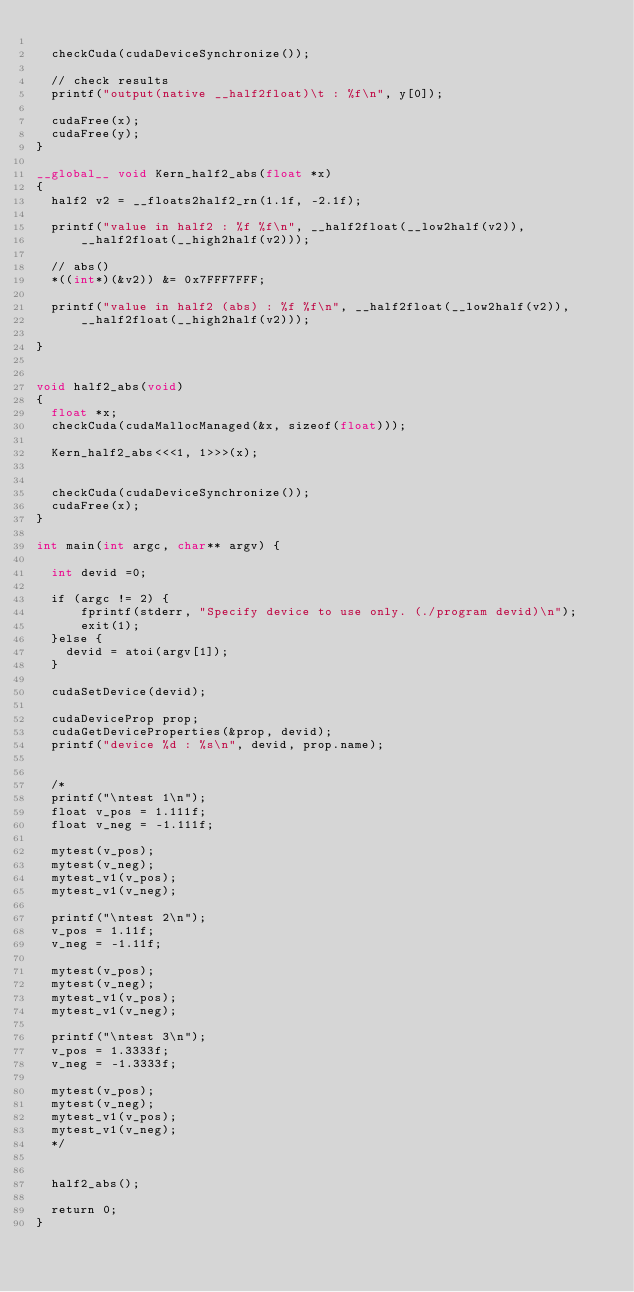<code> <loc_0><loc_0><loc_500><loc_500><_Cuda_>
  checkCuda(cudaDeviceSynchronize());
  
  // check results
  printf("output(native __half2float)\t : %f\n", y[0]);

  cudaFree(x);
  cudaFree(y);
}

__global__ void Kern_half2_abs(float *x)
{
	half2 v2 = __floats2half2_rn(1.1f, -2.1f);

	printf("value in half2 : %f %f\n", __half2float(__low2half(v2)),
			__half2float(__high2half(v2)));

	// abs()
	*((int*)(&v2)) &= 0x7FFF7FFF;

	printf("value in half2 (abs) : %f %f\n", __half2float(__low2half(v2)),
			__half2float(__high2half(v2)));

}


void half2_abs(void)
{
  float *x;
  checkCuda(cudaMallocManaged(&x, sizeof(float)));

  Kern_half2_abs<<<1, 1>>>(x);


  checkCuda(cudaDeviceSynchronize());
  cudaFree(x);
}

int main(int argc, char** argv) {

  int devid =0;

  if (argc != 2) {
      fprintf(stderr, "Specify device to use only. (./program devid)\n");
      exit(1);
  }else {
  	devid = atoi(argv[1]);
  }

  cudaSetDevice(devid);

  cudaDeviceProp prop;                                                    
  cudaGetDeviceProperties(&prop, devid);                                 
  printf("device %d : %s\n", devid, prop.name);


  /*
  printf("\ntest 1\n");
  float v_pos = 1.111f;
  float v_neg = -1.111f;

  mytest(v_pos);
  mytest(v_neg);
  mytest_v1(v_pos);
  mytest_v1(v_neg);

  printf("\ntest 2\n");
  v_pos = 1.11f;
  v_neg = -1.11f;

  mytest(v_pos);
  mytest(v_neg);
  mytest_v1(v_pos);
  mytest_v1(v_neg);

  printf("\ntest 3\n");
  v_pos = 1.3333f;
  v_neg = -1.3333f;

  mytest(v_pos);
  mytest(v_neg);
  mytest_v1(v_pos);
  mytest_v1(v_neg);
  */


  half2_abs();

  return 0;
}
</code> 